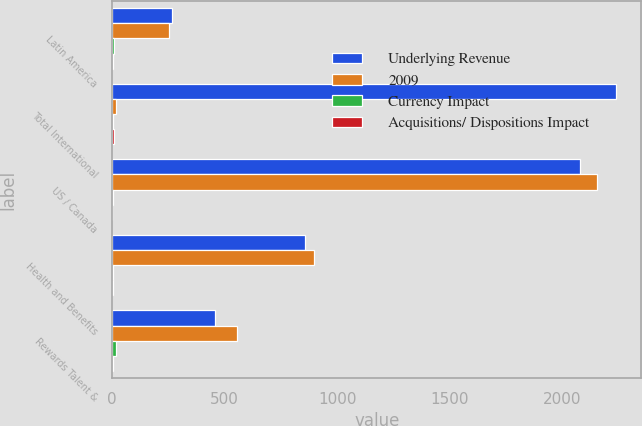Convert chart to OTSL. <chart><loc_0><loc_0><loc_500><loc_500><stacked_bar_chart><ecel><fcel>Latin America<fcel>Total International<fcel>US / Canada<fcel>Health and Benefits<fcel>Rewards Talent &<nl><fcel>Underlying Revenue<fcel>267<fcel>2241<fcel>2078<fcel>857<fcel>456<nl><fcel>2009<fcel>252<fcel>18<fcel>2154<fcel>898<fcel>555<nl><fcel>Currency Impact<fcel>6<fcel>5<fcel>4<fcel>5<fcel>18<nl><fcel>Acquisitions/ Dispositions Impact<fcel>5<fcel>6<fcel>1<fcel>3<fcel>2<nl></chart> 